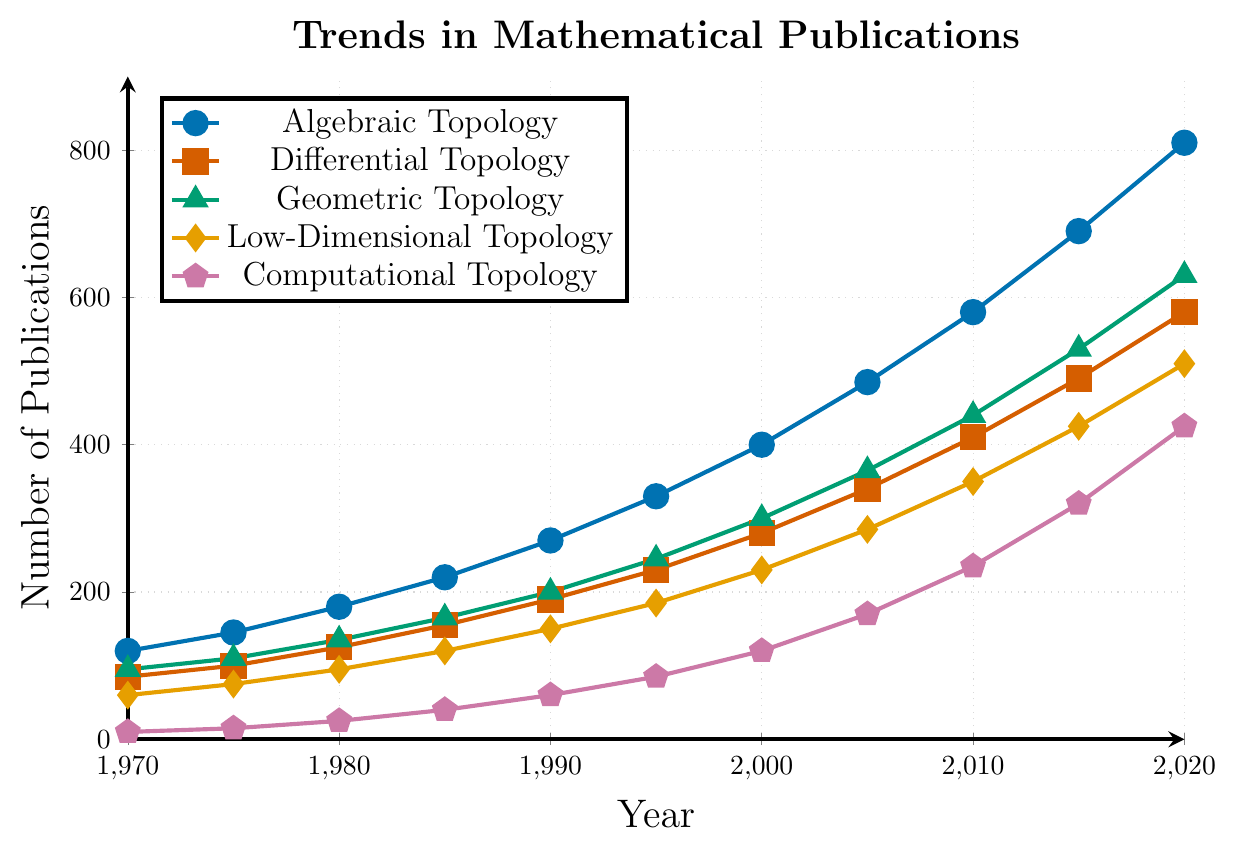Which subfield had the highest number of publications in the year 2000? In the year 2000, observe the y-axis values for each subfield’s line. Algebraic Topology is the highest with approximately 400 publications.
Answer: Algebraic Topology Between 1970 and 1980, how many total publications were added across all subfields? Calculate the increase for each subfield from 1970 to 1980 and sum the results: (180-120) + (125-85) + (135-95) + (95-60) + (25-10) = 60 + 40 + 40 + 35 + 15 = 190.
Answer: 190 Which subfield showed the least growth from 1970 to 2020? Compare the differences in the number of publications from 1970 to 2020 for each subfield. Compute: Algebraic Topology (810-120), Differential Topology (580-85), Geometric Topology (630-95), Low-Dimensional Topology (510-60), Computational Topology (425-10). Computational Topology has the smallest increase of 415 publications.
Answer: Computational Topology In which decade did Geometric Topology surpass Differential Topology in the number of publications? Observe the intersection points of Geometric Topology (green) and Differential Topology (red) lines. Geometric Topology surpasses Differential Topology between the years 1985 and 1990.
Answer: 1980s What is the approximate average number of publications in Low-Dimensional Topology over the given years? Sum the number of publications in Low-Dimensional Topology from 1970 to 2020 and divide by the number of data points (11). Calculation: (60 + 75 + 95 + 120 + 150 + 185 + 230 + 285 + 350 + 425 + 510) / 11 = 2485 / 11 ≈ 226.
Answer: 226 By how much did Computational Topology's publications increase from 1980 to 2010? Calculate the difference for Computational Topology between 1980 and 2010: 235 - 25 = 210.
Answer: 210 Which subfield had more publications in 1985: Algebraic Topology or Geometric Topology? Compare the y-axis values for Algebraic Topology (220) and Geometric Topology (165) in 1985. Algebraic Topology had more publications.
Answer: Algebraic Topology In which year did Algebraic Topology first surpass 500 publications? Check where the Algebraic Topology line crosses the 500 mark on the y-axis. It first surpasses in the year between 2005 (485) and 2010 (580).
Answer: 2010 Rank the subfields in ascending order of their publications in the year 1990. Compare the number of publications for each subfield in 1990: Algebraic Topology (270), Differential Topology (190), Geometric Topology (200), Low-Dimensional Topology (150), Computational Topology (60). Ascending order: Computational Topology, Low-Dimensional Topology, Differential Topology, Geometric Topology, Algebraic Topology.
Answer: Computational Topology, Low-Dimensional Topology, Differential Topology, Geometric Topology, Algebraic Topology 